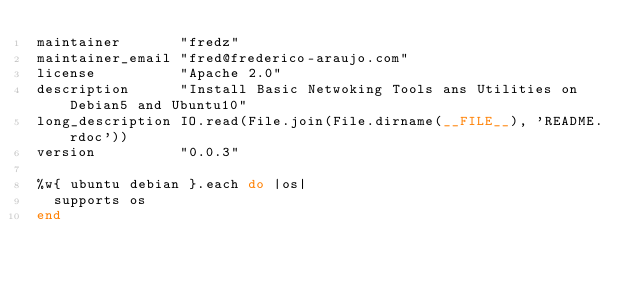Convert code to text. <code><loc_0><loc_0><loc_500><loc_500><_Ruby_>maintainer       "fredz"
maintainer_email "fred@frederico-araujo.com"
license          "Apache 2.0"
description      "Install Basic Netwoking Tools ans Utilities on Debian5 and Ubuntu10"
long_description IO.read(File.join(File.dirname(__FILE__), 'README.rdoc'))
version          "0.0.3"

%w{ ubuntu debian }.each do |os|
  supports os
end
</code> 